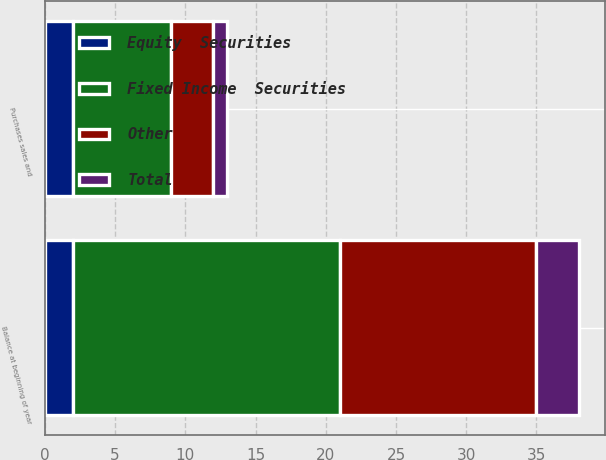Convert chart to OTSL. <chart><loc_0><loc_0><loc_500><loc_500><stacked_bar_chart><ecel><fcel>Balance at beginning of year<fcel>Purchases sales and<nl><fcel>Other<fcel>14<fcel>3<nl><fcel>Fixed Income  Securities<fcel>19<fcel>7<nl><fcel>Equity  Securities<fcel>2<fcel>2<nl><fcel>Total<fcel>3<fcel>1<nl></chart> 